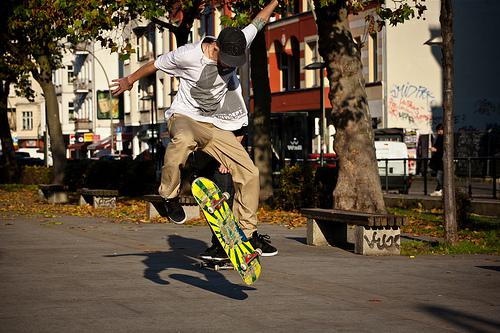Question: where is he skating?
Choices:
A. On the ice.
B. In the park.
C. On the lake.
D. At a rink.
Answer with the letter. Answer: B Question: who is with the skater?
Choices:
A. Boyfreind.
B. Girlfreind.
C. A friend.
D. Sister.
Answer with the letter. Answer: C 